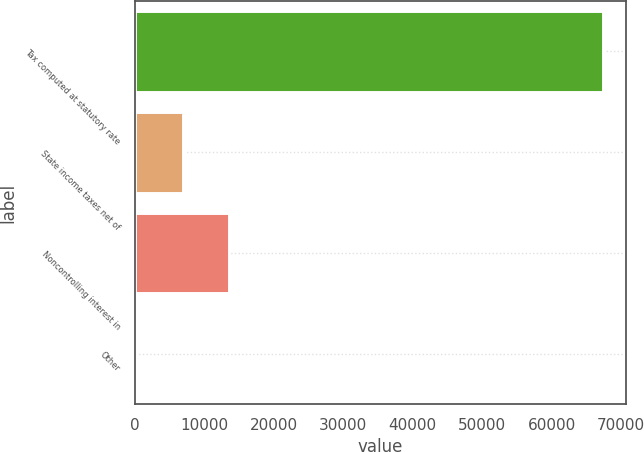Convert chart. <chart><loc_0><loc_0><loc_500><loc_500><bar_chart><fcel>Tax computed at statutory rate<fcel>State income taxes net of<fcel>Noncontrolling interest in<fcel>Other<nl><fcel>67327<fcel>6851.5<fcel>13571<fcel>132<nl></chart> 